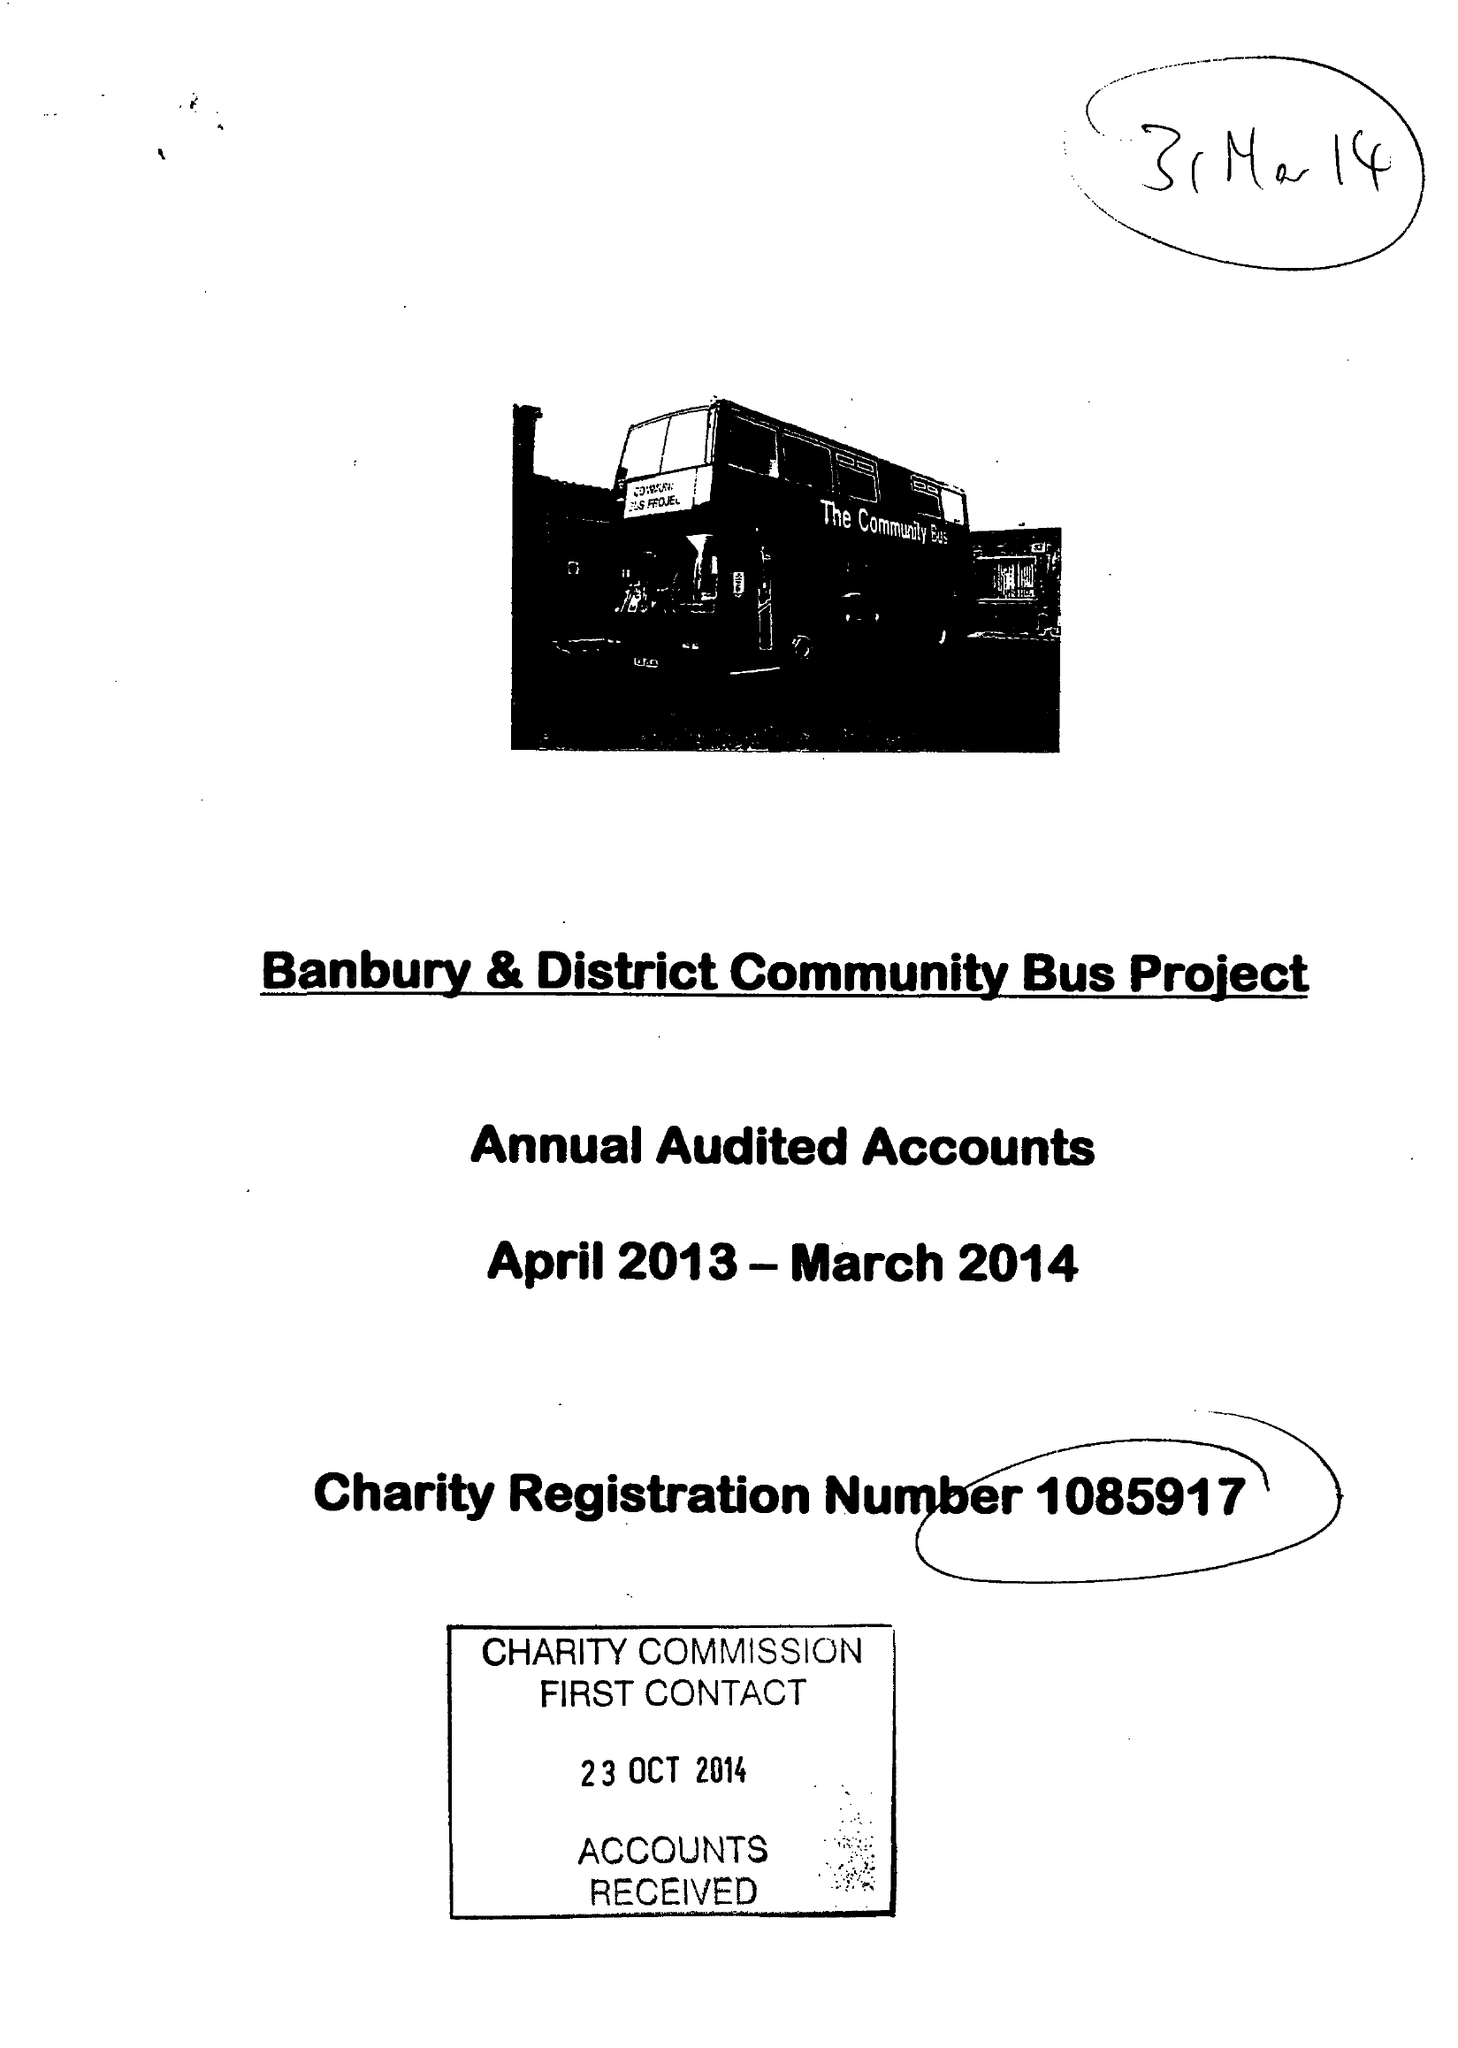What is the value for the charity_number?
Answer the question using a single word or phrase. 1085917 